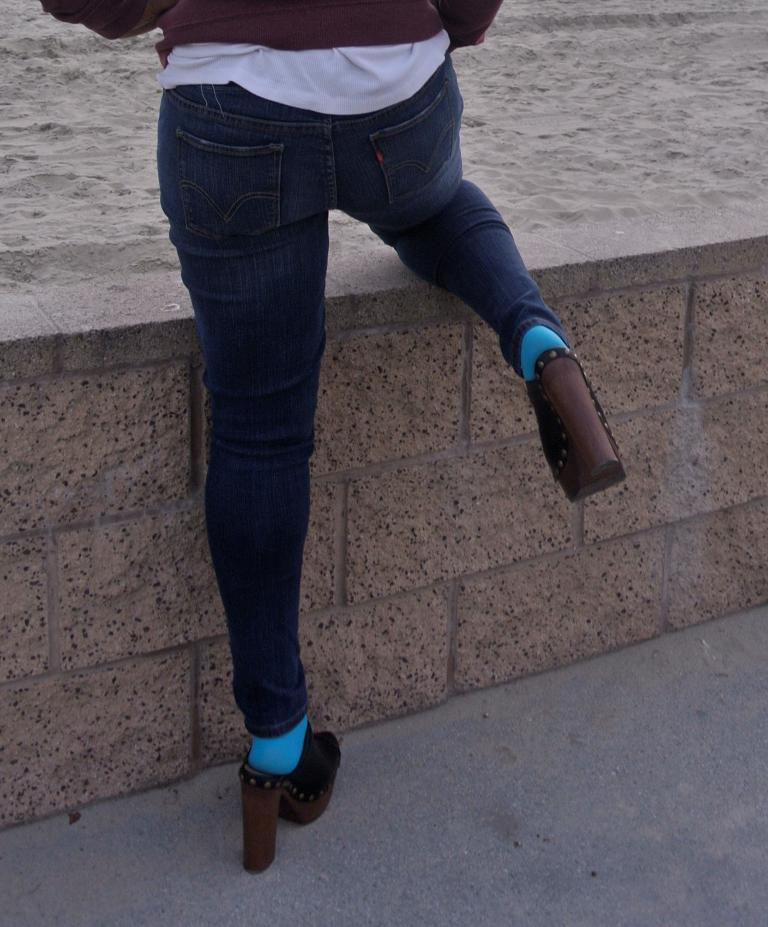What is present in the image that serves as a barrier or divider? There is a wall in the image. What is located above the wall? There is sand above the wall. Can you describe the person in the image? There is a person in front of the wall, and they are putting one of their legs on the wall. What type of appliance can be seen on the wall in the image? There is no appliance present on the wall in the image. What color is the cloth draped over the person's leg in the image? There is no cloth draped over the person's leg in the image. 